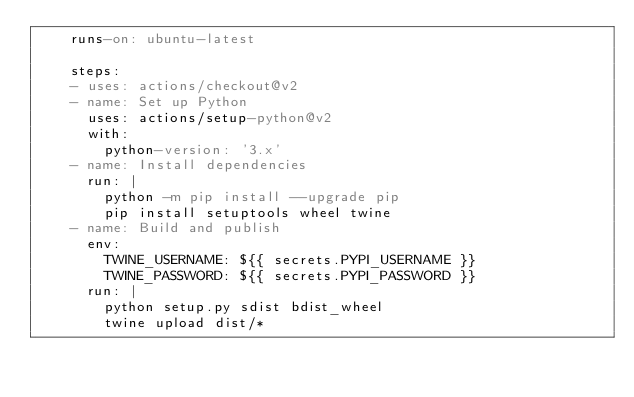Convert code to text. <code><loc_0><loc_0><loc_500><loc_500><_YAML_>    runs-on: ubuntu-latest

    steps:
    - uses: actions/checkout@v2
    - name: Set up Python
      uses: actions/setup-python@v2
      with:
        python-version: '3.x'
    - name: Install dependencies
      run: |
        python -m pip install --upgrade pip
        pip install setuptools wheel twine
    - name: Build and publish
      env:
        TWINE_USERNAME: ${{ secrets.PYPI_USERNAME }}
        TWINE_PASSWORD: ${{ secrets.PYPI_PASSWORD }}
      run: |
        python setup.py sdist bdist_wheel
        twine upload dist/*
</code> 